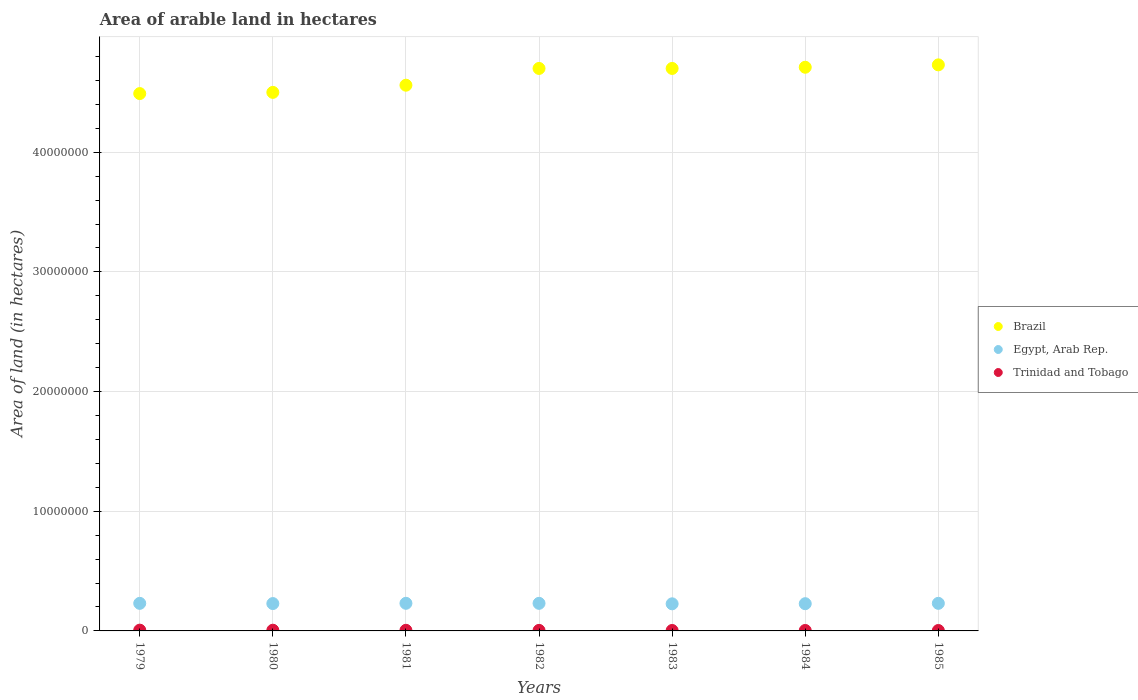What is the total arable land in Trinidad and Tobago in 1979?
Your response must be concise. 6.50e+04. Across all years, what is the maximum total arable land in Trinidad and Tobago?
Provide a short and direct response. 6.50e+04. Across all years, what is the minimum total arable land in Egypt, Arab Rep.?
Ensure brevity in your answer.  2.26e+06. In which year was the total arable land in Trinidad and Tobago maximum?
Provide a short and direct response. 1979. What is the total total arable land in Trinidad and Tobago in the graph?
Ensure brevity in your answer.  3.33e+05. What is the difference between the total arable land in Egypt, Arab Rep. in 1980 and that in 1982?
Your response must be concise. -1.90e+04. What is the difference between the total arable land in Trinidad and Tobago in 1985 and the total arable land in Egypt, Arab Rep. in 1981?
Ensure brevity in your answer.  -2.27e+06. What is the average total arable land in Egypt, Arab Rep. per year?
Ensure brevity in your answer.  2.29e+06. In the year 1985, what is the difference between the total arable land in Egypt, Arab Rep. and total arable land in Brazil?
Your answer should be compact. -4.50e+07. What is the ratio of the total arable land in Egypt, Arab Rep. in 1980 to that in 1982?
Your answer should be compact. 0.99. Is the total arable land in Trinidad and Tobago in 1979 less than that in 1983?
Give a very brief answer. No. What is the difference between the highest and the lowest total arable land in Egypt, Arab Rep.?
Offer a terse response. 4.23e+04. Is the sum of the total arable land in Brazil in 1981 and 1985 greater than the maximum total arable land in Trinidad and Tobago across all years?
Your answer should be compact. Yes. Is it the case that in every year, the sum of the total arable land in Brazil and total arable land in Trinidad and Tobago  is greater than the total arable land in Egypt, Arab Rep.?
Make the answer very short. Yes. How many dotlines are there?
Give a very brief answer. 3. Are the values on the major ticks of Y-axis written in scientific E-notation?
Keep it short and to the point. No. Where does the legend appear in the graph?
Offer a very short reply. Center right. What is the title of the graph?
Your answer should be very brief. Area of arable land in hectares. Does "Latin America(developing only)" appear as one of the legend labels in the graph?
Make the answer very short. No. What is the label or title of the Y-axis?
Provide a succinct answer. Area of land (in hectares). What is the Area of land (in hectares) of Brazil in 1979?
Offer a very short reply. 4.49e+07. What is the Area of land (in hectares) of Egypt, Arab Rep. in 1979?
Offer a very short reply. 2.30e+06. What is the Area of land (in hectares) in Trinidad and Tobago in 1979?
Make the answer very short. 6.50e+04. What is the Area of land (in hectares) of Brazil in 1980?
Your answer should be compact. 4.50e+07. What is the Area of land (in hectares) of Egypt, Arab Rep. in 1980?
Make the answer very short. 2.29e+06. What is the Area of land (in hectares) of Brazil in 1981?
Your answer should be compact. 4.56e+07. What is the Area of land (in hectares) of Egypt, Arab Rep. in 1981?
Provide a short and direct response. 2.31e+06. What is the Area of land (in hectares) in Trinidad and Tobago in 1981?
Your answer should be very brief. 5.20e+04. What is the Area of land (in hectares) in Brazil in 1982?
Keep it short and to the point. 4.70e+07. What is the Area of land (in hectares) of Egypt, Arab Rep. in 1982?
Provide a succinct answer. 2.30e+06. What is the Area of land (in hectares) in Trinidad and Tobago in 1982?
Provide a succinct answer. 4.50e+04. What is the Area of land (in hectares) of Brazil in 1983?
Make the answer very short. 4.70e+07. What is the Area of land (in hectares) of Egypt, Arab Rep. in 1983?
Provide a succinct answer. 2.26e+06. What is the Area of land (in hectares) in Trinidad and Tobago in 1983?
Offer a very short reply. 3.80e+04. What is the Area of land (in hectares) of Brazil in 1984?
Your answer should be very brief. 4.71e+07. What is the Area of land (in hectares) of Egypt, Arab Rep. in 1984?
Ensure brevity in your answer.  2.28e+06. What is the Area of land (in hectares) in Trinidad and Tobago in 1984?
Offer a very short reply. 3.80e+04. What is the Area of land (in hectares) of Brazil in 1985?
Make the answer very short. 4.73e+07. What is the Area of land (in hectares) of Egypt, Arab Rep. in 1985?
Offer a very short reply. 2.30e+06. What is the Area of land (in hectares) of Trinidad and Tobago in 1985?
Your answer should be compact. 3.50e+04. Across all years, what is the maximum Area of land (in hectares) in Brazil?
Give a very brief answer. 4.73e+07. Across all years, what is the maximum Area of land (in hectares) of Egypt, Arab Rep.?
Offer a terse response. 2.31e+06. Across all years, what is the maximum Area of land (in hectares) in Trinidad and Tobago?
Make the answer very short. 6.50e+04. Across all years, what is the minimum Area of land (in hectares) of Brazil?
Your answer should be compact. 4.49e+07. Across all years, what is the minimum Area of land (in hectares) in Egypt, Arab Rep.?
Make the answer very short. 2.26e+06. Across all years, what is the minimum Area of land (in hectares) of Trinidad and Tobago?
Keep it short and to the point. 3.50e+04. What is the total Area of land (in hectares) of Brazil in the graph?
Your answer should be very brief. 3.24e+08. What is the total Area of land (in hectares) of Egypt, Arab Rep. in the graph?
Keep it short and to the point. 1.60e+07. What is the total Area of land (in hectares) of Trinidad and Tobago in the graph?
Your response must be concise. 3.33e+05. What is the difference between the Area of land (in hectares) of Brazil in 1979 and that in 1980?
Your answer should be very brief. -1.00e+05. What is the difference between the Area of land (in hectares) of Egypt, Arab Rep. in 1979 and that in 1980?
Offer a very short reply. 1.80e+04. What is the difference between the Area of land (in hectares) in Brazil in 1979 and that in 1981?
Give a very brief answer. -7.00e+05. What is the difference between the Area of land (in hectares) of Egypt, Arab Rep. in 1979 and that in 1981?
Your answer should be compact. -3000. What is the difference between the Area of land (in hectares) in Trinidad and Tobago in 1979 and that in 1981?
Offer a very short reply. 1.30e+04. What is the difference between the Area of land (in hectares) in Brazil in 1979 and that in 1982?
Ensure brevity in your answer.  -2.10e+06. What is the difference between the Area of land (in hectares) in Egypt, Arab Rep. in 1979 and that in 1982?
Provide a succinct answer. -1000. What is the difference between the Area of land (in hectares) of Trinidad and Tobago in 1979 and that in 1982?
Offer a terse response. 2.00e+04. What is the difference between the Area of land (in hectares) of Brazil in 1979 and that in 1983?
Your answer should be very brief. -2.10e+06. What is the difference between the Area of land (in hectares) in Egypt, Arab Rep. in 1979 and that in 1983?
Your answer should be compact. 3.93e+04. What is the difference between the Area of land (in hectares) in Trinidad and Tobago in 1979 and that in 1983?
Make the answer very short. 2.70e+04. What is the difference between the Area of land (in hectares) of Brazil in 1979 and that in 1984?
Give a very brief answer. -2.20e+06. What is the difference between the Area of land (in hectares) in Egypt, Arab Rep. in 1979 and that in 1984?
Offer a very short reply. 2.87e+04. What is the difference between the Area of land (in hectares) of Trinidad and Tobago in 1979 and that in 1984?
Your answer should be very brief. 2.70e+04. What is the difference between the Area of land (in hectares) of Brazil in 1979 and that in 1985?
Your answer should be very brief. -2.40e+06. What is the difference between the Area of land (in hectares) in Egypt, Arab Rep. in 1979 and that in 1985?
Your answer should be very brief. -1000. What is the difference between the Area of land (in hectares) of Brazil in 1980 and that in 1981?
Give a very brief answer. -6.00e+05. What is the difference between the Area of land (in hectares) in Egypt, Arab Rep. in 1980 and that in 1981?
Ensure brevity in your answer.  -2.10e+04. What is the difference between the Area of land (in hectares) in Trinidad and Tobago in 1980 and that in 1981?
Make the answer very short. 8000. What is the difference between the Area of land (in hectares) in Brazil in 1980 and that in 1982?
Your response must be concise. -2.00e+06. What is the difference between the Area of land (in hectares) of Egypt, Arab Rep. in 1980 and that in 1982?
Your answer should be very brief. -1.90e+04. What is the difference between the Area of land (in hectares) of Trinidad and Tobago in 1980 and that in 1982?
Your answer should be compact. 1.50e+04. What is the difference between the Area of land (in hectares) in Egypt, Arab Rep. in 1980 and that in 1983?
Keep it short and to the point. 2.13e+04. What is the difference between the Area of land (in hectares) of Trinidad and Tobago in 1980 and that in 1983?
Give a very brief answer. 2.20e+04. What is the difference between the Area of land (in hectares) in Brazil in 1980 and that in 1984?
Make the answer very short. -2.10e+06. What is the difference between the Area of land (in hectares) in Egypt, Arab Rep. in 1980 and that in 1984?
Provide a short and direct response. 1.07e+04. What is the difference between the Area of land (in hectares) of Trinidad and Tobago in 1980 and that in 1984?
Offer a terse response. 2.20e+04. What is the difference between the Area of land (in hectares) in Brazil in 1980 and that in 1985?
Offer a terse response. -2.30e+06. What is the difference between the Area of land (in hectares) of Egypt, Arab Rep. in 1980 and that in 1985?
Provide a short and direct response. -1.90e+04. What is the difference between the Area of land (in hectares) in Trinidad and Tobago in 1980 and that in 1985?
Offer a terse response. 2.50e+04. What is the difference between the Area of land (in hectares) in Brazil in 1981 and that in 1982?
Keep it short and to the point. -1.40e+06. What is the difference between the Area of land (in hectares) in Trinidad and Tobago in 1981 and that in 1982?
Keep it short and to the point. 7000. What is the difference between the Area of land (in hectares) of Brazil in 1981 and that in 1983?
Give a very brief answer. -1.40e+06. What is the difference between the Area of land (in hectares) in Egypt, Arab Rep. in 1981 and that in 1983?
Your response must be concise. 4.23e+04. What is the difference between the Area of land (in hectares) of Trinidad and Tobago in 1981 and that in 1983?
Provide a succinct answer. 1.40e+04. What is the difference between the Area of land (in hectares) of Brazil in 1981 and that in 1984?
Offer a very short reply. -1.50e+06. What is the difference between the Area of land (in hectares) of Egypt, Arab Rep. in 1981 and that in 1984?
Ensure brevity in your answer.  3.17e+04. What is the difference between the Area of land (in hectares) in Trinidad and Tobago in 1981 and that in 1984?
Provide a succinct answer. 1.40e+04. What is the difference between the Area of land (in hectares) in Brazil in 1981 and that in 1985?
Offer a terse response. -1.70e+06. What is the difference between the Area of land (in hectares) of Egypt, Arab Rep. in 1981 and that in 1985?
Make the answer very short. 2000. What is the difference between the Area of land (in hectares) of Trinidad and Tobago in 1981 and that in 1985?
Make the answer very short. 1.70e+04. What is the difference between the Area of land (in hectares) in Brazil in 1982 and that in 1983?
Give a very brief answer. 0. What is the difference between the Area of land (in hectares) in Egypt, Arab Rep. in 1982 and that in 1983?
Your response must be concise. 4.03e+04. What is the difference between the Area of land (in hectares) in Trinidad and Tobago in 1982 and that in 1983?
Offer a terse response. 7000. What is the difference between the Area of land (in hectares) in Brazil in 1982 and that in 1984?
Provide a short and direct response. -1.00e+05. What is the difference between the Area of land (in hectares) in Egypt, Arab Rep. in 1982 and that in 1984?
Make the answer very short. 2.97e+04. What is the difference between the Area of land (in hectares) of Trinidad and Tobago in 1982 and that in 1984?
Provide a succinct answer. 7000. What is the difference between the Area of land (in hectares) in Egypt, Arab Rep. in 1983 and that in 1984?
Ensure brevity in your answer.  -1.05e+04. What is the difference between the Area of land (in hectares) of Trinidad and Tobago in 1983 and that in 1984?
Provide a short and direct response. 0. What is the difference between the Area of land (in hectares) of Egypt, Arab Rep. in 1983 and that in 1985?
Keep it short and to the point. -4.03e+04. What is the difference between the Area of land (in hectares) in Trinidad and Tobago in 1983 and that in 1985?
Your answer should be compact. 3000. What is the difference between the Area of land (in hectares) in Egypt, Arab Rep. in 1984 and that in 1985?
Make the answer very short. -2.97e+04. What is the difference between the Area of land (in hectares) in Trinidad and Tobago in 1984 and that in 1985?
Keep it short and to the point. 3000. What is the difference between the Area of land (in hectares) in Brazil in 1979 and the Area of land (in hectares) in Egypt, Arab Rep. in 1980?
Ensure brevity in your answer.  4.26e+07. What is the difference between the Area of land (in hectares) in Brazil in 1979 and the Area of land (in hectares) in Trinidad and Tobago in 1980?
Offer a terse response. 4.48e+07. What is the difference between the Area of land (in hectares) in Egypt, Arab Rep. in 1979 and the Area of land (in hectares) in Trinidad and Tobago in 1980?
Keep it short and to the point. 2.24e+06. What is the difference between the Area of land (in hectares) of Brazil in 1979 and the Area of land (in hectares) of Egypt, Arab Rep. in 1981?
Give a very brief answer. 4.26e+07. What is the difference between the Area of land (in hectares) of Brazil in 1979 and the Area of land (in hectares) of Trinidad and Tobago in 1981?
Provide a succinct answer. 4.48e+07. What is the difference between the Area of land (in hectares) in Egypt, Arab Rep. in 1979 and the Area of land (in hectares) in Trinidad and Tobago in 1981?
Make the answer very short. 2.25e+06. What is the difference between the Area of land (in hectares) of Brazil in 1979 and the Area of land (in hectares) of Egypt, Arab Rep. in 1982?
Provide a short and direct response. 4.26e+07. What is the difference between the Area of land (in hectares) of Brazil in 1979 and the Area of land (in hectares) of Trinidad and Tobago in 1982?
Give a very brief answer. 4.49e+07. What is the difference between the Area of land (in hectares) of Egypt, Arab Rep. in 1979 and the Area of land (in hectares) of Trinidad and Tobago in 1982?
Ensure brevity in your answer.  2.26e+06. What is the difference between the Area of land (in hectares) in Brazil in 1979 and the Area of land (in hectares) in Egypt, Arab Rep. in 1983?
Your answer should be compact. 4.26e+07. What is the difference between the Area of land (in hectares) in Brazil in 1979 and the Area of land (in hectares) in Trinidad and Tobago in 1983?
Ensure brevity in your answer.  4.49e+07. What is the difference between the Area of land (in hectares) in Egypt, Arab Rep. in 1979 and the Area of land (in hectares) in Trinidad and Tobago in 1983?
Offer a terse response. 2.27e+06. What is the difference between the Area of land (in hectares) of Brazil in 1979 and the Area of land (in hectares) of Egypt, Arab Rep. in 1984?
Ensure brevity in your answer.  4.26e+07. What is the difference between the Area of land (in hectares) in Brazil in 1979 and the Area of land (in hectares) in Trinidad and Tobago in 1984?
Provide a short and direct response. 4.49e+07. What is the difference between the Area of land (in hectares) of Egypt, Arab Rep. in 1979 and the Area of land (in hectares) of Trinidad and Tobago in 1984?
Your response must be concise. 2.27e+06. What is the difference between the Area of land (in hectares) in Brazil in 1979 and the Area of land (in hectares) in Egypt, Arab Rep. in 1985?
Provide a succinct answer. 4.26e+07. What is the difference between the Area of land (in hectares) in Brazil in 1979 and the Area of land (in hectares) in Trinidad and Tobago in 1985?
Provide a succinct answer. 4.49e+07. What is the difference between the Area of land (in hectares) of Egypt, Arab Rep. in 1979 and the Area of land (in hectares) of Trinidad and Tobago in 1985?
Provide a short and direct response. 2.27e+06. What is the difference between the Area of land (in hectares) of Brazil in 1980 and the Area of land (in hectares) of Egypt, Arab Rep. in 1981?
Your answer should be compact. 4.27e+07. What is the difference between the Area of land (in hectares) in Brazil in 1980 and the Area of land (in hectares) in Trinidad and Tobago in 1981?
Offer a very short reply. 4.49e+07. What is the difference between the Area of land (in hectares) of Egypt, Arab Rep. in 1980 and the Area of land (in hectares) of Trinidad and Tobago in 1981?
Ensure brevity in your answer.  2.23e+06. What is the difference between the Area of land (in hectares) of Brazil in 1980 and the Area of land (in hectares) of Egypt, Arab Rep. in 1982?
Keep it short and to the point. 4.27e+07. What is the difference between the Area of land (in hectares) of Brazil in 1980 and the Area of land (in hectares) of Trinidad and Tobago in 1982?
Your answer should be very brief. 4.50e+07. What is the difference between the Area of land (in hectares) in Egypt, Arab Rep. in 1980 and the Area of land (in hectares) in Trinidad and Tobago in 1982?
Offer a very short reply. 2.24e+06. What is the difference between the Area of land (in hectares) in Brazil in 1980 and the Area of land (in hectares) in Egypt, Arab Rep. in 1983?
Your response must be concise. 4.27e+07. What is the difference between the Area of land (in hectares) in Brazil in 1980 and the Area of land (in hectares) in Trinidad and Tobago in 1983?
Your response must be concise. 4.50e+07. What is the difference between the Area of land (in hectares) in Egypt, Arab Rep. in 1980 and the Area of land (in hectares) in Trinidad and Tobago in 1983?
Ensure brevity in your answer.  2.25e+06. What is the difference between the Area of land (in hectares) of Brazil in 1980 and the Area of land (in hectares) of Egypt, Arab Rep. in 1984?
Keep it short and to the point. 4.27e+07. What is the difference between the Area of land (in hectares) of Brazil in 1980 and the Area of land (in hectares) of Trinidad and Tobago in 1984?
Provide a short and direct response. 4.50e+07. What is the difference between the Area of land (in hectares) in Egypt, Arab Rep. in 1980 and the Area of land (in hectares) in Trinidad and Tobago in 1984?
Ensure brevity in your answer.  2.25e+06. What is the difference between the Area of land (in hectares) in Brazil in 1980 and the Area of land (in hectares) in Egypt, Arab Rep. in 1985?
Your answer should be very brief. 4.27e+07. What is the difference between the Area of land (in hectares) in Brazil in 1980 and the Area of land (in hectares) in Trinidad and Tobago in 1985?
Your answer should be compact. 4.50e+07. What is the difference between the Area of land (in hectares) in Egypt, Arab Rep. in 1980 and the Area of land (in hectares) in Trinidad and Tobago in 1985?
Make the answer very short. 2.25e+06. What is the difference between the Area of land (in hectares) of Brazil in 1981 and the Area of land (in hectares) of Egypt, Arab Rep. in 1982?
Ensure brevity in your answer.  4.33e+07. What is the difference between the Area of land (in hectares) of Brazil in 1981 and the Area of land (in hectares) of Trinidad and Tobago in 1982?
Ensure brevity in your answer.  4.56e+07. What is the difference between the Area of land (in hectares) of Egypt, Arab Rep. in 1981 and the Area of land (in hectares) of Trinidad and Tobago in 1982?
Provide a succinct answer. 2.26e+06. What is the difference between the Area of land (in hectares) of Brazil in 1981 and the Area of land (in hectares) of Egypt, Arab Rep. in 1983?
Provide a succinct answer. 4.33e+07. What is the difference between the Area of land (in hectares) of Brazil in 1981 and the Area of land (in hectares) of Trinidad and Tobago in 1983?
Ensure brevity in your answer.  4.56e+07. What is the difference between the Area of land (in hectares) of Egypt, Arab Rep. in 1981 and the Area of land (in hectares) of Trinidad and Tobago in 1983?
Provide a short and direct response. 2.27e+06. What is the difference between the Area of land (in hectares) of Brazil in 1981 and the Area of land (in hectares) of Egypt, Arab Rep. in 1984?
Your answer should be compact. 4.33e+07. What is the difference between the Area of land (in hectares) of Brazil in 1981 and the Area of land (in hectares) of Trinidad and Tobago in 1984?
Provide a succinct answer. 4.56e+07. What is the difference between the Area of land (in hectares) in Egypt, Arab Rep. in 1981 and the Area of land (in hectares) in Trinidad and Tobago in 1984?
Keep it short and to the point. 2.27e+06. What is the difference between the Area of land (in hectares) in Brazil in 1981 and the Area of land (in hectares) in Egypt, Arab Rep. in 1985?
Offer a terse response. 4.33e+07. What is the difference between the Area of land (in hectares) in Brazil in 1981 and the Area of land (in hectares) in Trinidad and Tobago in 1985?
Your answer should be compact. 4.56e+07. What is the difference between the Area of land (in hectares) of Egypt, Arab Rep. in 1981 and the Area of land (in hectares) of Trinidad and Tobago in 1985?
Your response must be concise. 2.27e+06. What is the difference between the Area of land (in hectares) of Brazil in 1982 and the Area of land (in hectares) of Egypt, Arab Rep. in 1983?
Keep it short and to the point. 4.47e+07. What is the difference between the Area of land (in hectares) in Brazil in 1982 and the Area of land (in hectares) in Trinidad and Tobago in 1983?
Your answer should be very brief. 4.70e+07. What is the difference between the Area of land (in hectares) in Egypt, Arab Rep. in 1982 and the Area of land (in hectares) in Trinidad and Tobago in 1983?
Your answer should be very brief. 2.27e+06. What is the difference between the Area of land (in hectares) in Brazil in 1982 and the Area of land (in hectares) in Egypt, Arab Rep. in 1984?
Your answer should be very brief. 4.47e+07. What is the difference between the Area of land (in hectares) of Brazil in 1982 and the Area of land (in hectares) of Trinidad and Tobago in 1984?
Make the answer very short. 4.70e+07. What is the difference between the Area of land (in hectares) of Egypt, Arab Rep. in 1982 and the Area of land (in hectares) of Trinidad and Tobago in 1984?
Your response must be concise. 2.27e+06. What is the difference between the Area of land (in hectares) of Brazil in 1982 and the Area of land (in hectares) of Egypt, Arab Rep. in 1985?
Make the answer very short. 4.47e+07. What is the difference between the Area of land (in hectares) in Brazil in 1982 and the Area of land (in hectares) in Trinidad and Tobago in 1985?
Make the answer very short. 4.70e+07. What is the difference between the Area of land (in hectares) in Egypt, Arab Rep. in 1982 and the Area of land (in hectares) in Trinidad and Tobago in 1985?
Keep it short and to the point. 2.27e+06. What is the difference between the Area of land (in hectares) in Brazil in 1983 and the Area of land (in hectares) in Egypt, Arab Rep. in 1984?
Your response must be concise. 4.47e+07. What is the difference between the Area of land (in hectares) in Brazil in 1983 and the Area of land (in hectares) in Trinidad and Tobago in 1984?
Give a very brief answer. 4.70e+07. What is the difference between the Area of land (in hectares) in Egypt, Arab Rep. in 1983 and the Area of land (in hectares) in Trinidad and Tobago in 1984?
Make the answer very short. 2.23e+06. What is the difference between the Area of land (in hectares) of Brazil in 1983 and the Area of land (in hectares) of Egypt, Arab Rep. in 1985?
Ensure brevity in your answer.  4.47e+07. What is the difference between the Area of land (in hectares) in Brazil in 1983 and the Area of land (in hectares) in Trinidad and Tobago in 1985?
Make the answer very short. 4.70e+07. What is the difference between the Area of land (in hectares) of Egypt, Arab Rep. in 1983 and the Area of land (in hectares) of Trinidad and Tobago in 1985?
Offer a terse response. 2.23e+06. What is the difference between the Area of land (in hectares) in Brazil in 1984 and the Area of land (in hectares) in Egypt, Arab Rep. in 1985?
Offer a very short reply. 4.48e+07. What is the difference between the Area of land (in hectares) of Brazil in 1984 and the Area of land (in hectares) of Trinidad and Tobago in 1985?
Give a very brief answer. 4.71e+07. What is the difference between the Area of land (in hectares) of Egypt, Arab Rep. in 1984 and the Area of land (in hectares) of Trinidad and Tobago in 1985?
Provide a short and direct response. 2.24e+06. What is the average Area of land (in hectares) in Brazil per year?
Your answer should be very brief. 4.63e+07. What is the average Area of land (in hectares) in Egypt, Arab Rep. per year?
Your answer should be compact. 2.29e+06. What is the average Area of land (in hectares) in Trinidad and Tobago per year?
Your response must be concise. 4.76e+04. In the year 1979, what is the difference between the Area of land (in hectares) in Brazil and Area of land (in hectares) in Egypt, Arab Rep.?
Make the answer very short. 4.26e+07. In the year 1979, what is the difference between the Area of land (in hectares) of Brazil and Area of land (in hectares) of Trinidad and Tobago?
Offer a very short reply. 4.48e+07. In the year 1979, what is the difference between the Area of land (in hectares) in Egypt, Arab Rep. and Area of land (in hectares) in Trinidad and Tobago?
Offer a very short reply. 2.24e+06. In the year 1980, what is the difference between the Area of land (in hectares) of Brazil and Area of land (in hectares) of Egypt, Arab Rep.?
Provide a succinct answer. 4.27e+07. In the year 1980, what is the difference between the Area of land (in hectares) in Brazil and Area of land (in hectares) in Trinidad and Tobago?
Give a very brief answer. 4.49e+07. In the year 1980, what is the difference between the Area of land (in hectares) in Egypt, Arab Rep. and Area of land (in hectares) in Trinidad and Tobago?
Give a very brief answer. 2.23e+06. In the year 1981, what is the difference between the Area of land (in hectares) in Brazil and Area of land (in hectares) in Egypt, Arab Rep.?
Offer a very short reply. 4.33e+07. In the year 1981, what is the difference between the Area of land (in hectares) in Brazil and Area of land (in hectares) in Trinidad and Tobago?
Offer a terse response. 4.55e+07. In the year 1981, what is the difference between the Area of land (in hectares) in Egypt, Arab Rep. and Area of land (in hectares) in Trinidad and Tobago?
Your answer should be compact. 2.26e+06. In the year 1982, what is the difference between the Area of land (in hectares) in Brazil and Area of land (in hectares) in Egypt, Arab Rep.?
Make the answer very short. 4.47e+07. In the year 1982, what is the difference between the Area of land (in hectares) in Brazil and Area of land (in hectares) in Trinidad and Tobago?
Your answer should be compact. 4.70e+07. In the year 1982, what is the difference between the Area of land (in hectares) in Egypt, Arab Rep. and Area of land (in hectares) in Trinidad and Tobago?
Your response must be concise. 2.26e+06. In the year 1983, what is the difference between the Area of land (in hectares) of Brazil and Area of land (in hectares) of Egypt, Arab Rep.?
Offer a very short reply. 4.47e+07. In the year 1983, what is the difference between the Area of land (in hectares) of Brazil and Area of land (in hectares) of Trinidad and Tobago?
Your answer should be very brief. 4.70e+07. In the year 1983, what is the difference between the Area of land (in hectares) of Egypt, Arab Rep. and Area of land (in hectares) of Trinidad and Tobago?
Your answer should be very brief. 2.23e+06. In the year 1984, what is the difference between the Area of land (in hectares) in Brazil and Area of land (in hectares) in Egypt, Arab Rep.?
Provide a short and direct response. 4.48e+07. In the year 1984, what is the difference between the Area of land (in hectares) in Brazil and Area of land (in hectares) in Trinidad and Tobago?
Offer a terse response. 4.71e+07. In the year 1984, what is the difference between the Area of land (in hectares) in Egypt, Arab Rep. and Area of land (in hectares) in Trinidad and Tobago?
Provide a short and direct response. 2.24e+06. In the year 1985, what is the difference between the Area of land (in hectares) of Brazil and Area of land (in hectares) of Egypt, Arab Rep.?
Offer a very short reply. 4.50e+07. In the year 1985, what is the difference between the Area of land (in hectares) in Brazil and Area of land (in hectares) in Trinidad and Tobago?
Ensure brevity in your answer.  4.73e+07. In the year 1985, what is the difference between the Area of land (in hectares) in Egypt, Arab Rep. and Area of land (in hectares) in Trinidad and Tobago?
Provide a short and direct response. 2.27e+06. What is the ratio of the Area of land (in hectares) in Brazil in 1979 to that in 1980?
Your answer should be compact. 1. What is the ratio of the Area of land (in hectares) in Egypt, Arab Rep. in 1979 to that in 1980?
Ensure brevity in your answer.  1.01. What is the ratio of the Area of land (in hectares) in Trinidad and Tobago in 1979 to that in 1980?
Provide a short and direct response. 1.08. What is the ratio of the Area of land (in hectares) of Brazil in 1979 to that in 1981?
Your answer should be very brief. 0.98. What is the ratio of the Area of land (in hectares) of Egypt, Arab Rep. in 1979 to that in 1981?
Your answer should be compact. 1. What is the ratio of the Area of land (in hectares) in Brazil in 1979 to that in 1982?
Offer a terse response. 0.96. What is the ratio of the Area of land (in hectares) in Egypt, Arab Rep. in 1979 to that in 1982?
Offer a terse response. 1. What is the ratio of the Area of land (in hectares) in Trinidad and Tobago in 1979 to that in 1982?
Offer a terse response. 1.44. What is the ratio of the Area of land (in hectares) of Brazil in 1979 to that in 1983?
Offer a very short reply. 0.96. What is the ratio of the Area of land (in hectares) of Egypt, Arab Rep. in 1979 to that in 1983?
Your answer should be very brief. 1.02. What is the ratio of the Area of land (in hectares) of Trinidad and Tobago in 1979 to that in 1983?
Your answer should be compact. 1.71. What is the ratio of the Area of land (in hectares) in Brazil in 1979 to that in 1984?
Keep it short and to the point. 0.95. What is the ratio of the Area of land (in hectares) in Egypt, Arab Rep. in 1979 to that in 1984?
Your response must be concise. 1.01. What is the ratio of the Area of land (in hectares) in Trinidad and Tobago in 1979 to that in 1984?
Provide a succinct answer. 1.71. What is the ratio of the Area of land (in hectares) in Brazil in 1979 to that in 1985?
Give a very brief answer. 0.95. What is the ratio of the Area of land (in hectares) in Egypt, Arab Rep. in 1979 to that in 1985?
Provide a short and direct response. 1. What is the ratio of the Area of land (in hectares) of Trinidad and Tobago in 1979 to that in 1985?
Provide a short and direct response. 1.86. What is the ratio of the Area of land (in hectares) of Brazil in 1980 to that in 1981?
Your answer should be compact. 0.99. What is the ratio of the Area of land (in hectares) of Egypt, Arab Rep. in 1980 to that in 1981?
Your response must be concise. 0.99. What is the ratio of the Area of land (in hectares) of Trinidad and Tobago in 1980 to that in 1981?
Provide a short and direct response. 1.15. What is the ratio of the Area of land (in hectares) in Brazil in 1980 to that in 1982?
Provide a short and direct response. 0.96. What is the ratio of the Area of land (in hectares) of Egypt, Arab Rep. in 1980 to that in 1982?
Your response must be concise. 0.99. What is the ratio of the Area of land (in hectares) in Brazil in 1980 to that in 1983?
Offer a very short reply. 0.96. What is the ratio of the Area of land (in hectares) of Egypt, Arab Rep. in 1980 to that in 1983?
Provide a short and direct response. 1.01. What is the ratio of the Area of land (in hectares) of Trinidad and Tobago in 1980 to that in 1983?
Ensure brevity in your answer.  1.58. What is the ratio of the Area of land (in hectares) of Brazil in 1980 to that in 1984?
Offer a terse response. 0.96. What is the ratio of the Area of land (in hectares) in Trinidad and Tobago in 1980 to that in 1984?
Your response must be concise. 1.58. What is the ratio of the Area of land (in hectares) of Brazil in 1980 to that in 1985?
Make the answer very short. 0.95. What is the ratio of the Area of land (in hectares) of Egypt, Arab Rep. in 1980 to that in 1985?
Keep it short and to the point. 0.99. What is the ratio of the Area of land (in hectares) of Trinidad and Tobago in 1980 to that in 1985?
Provide a short and direct response. 1.71. What is the ratio of the Area of land (in hectares) in Brazil in 1981 to that in 1982?
Offer a terse response. 0.97. What is the ratio of the Area of land (in hectares) in Trinidad and Tobago in 1981 to that in 1982?
Keep it short and to the point. 1.16. What is the ratio of the Area of land (in hectares) in Brazil in 1981 to that in 1983?
Keep it short and to the point. 0.97. What is the ratio of the Area of land (in hectares) in Egypt, Arab Rep. in 1981 to that in 1983?
Provide a short and direct response. 1.02. What is the ratio of the Area of land (in hectares) of Trinidad and Tobago in 1981 to that in 1983?
Provide a short and direct response. 1.37. What is the ratio of the Area of land (in hectares) of Brazil in 1981 to that in 1984?
Provide a short and direct response. 0.97. What is the ratio of the Area of land (in hectares) in Egypt, Arab Rep. in 1981 to that in 1984?
Your answer should be very brief. 1.01. What is the ratio of the Area of land (in hectares) of Trinidad and Tobago in 1981 to that in 1984?
Give a very brief answer. 1.37. What is the ratio of the Area of land (in hectares) of Brazil in 1981 to that in 1985?
Keep it short and to the point. 0.96. What is the ratio of the Area of land (in hectares) in Egypt, Arab Rep. in 1981 to that in 1985?
Offer a very short reply. 1. What is the ratio of the Area of land (in hectares) in Trinidad and Tobago in 1981 to that in 1985?
Provide a short and direct response. 1.49. What is the ratio of the Area of land (in hectares) in Brazil in 1982 to that in 1983?
Provide a short and direct response. 1. What is the ratio of the Area of land (in hectares) of Egypt, Arab Rep. in 1982 to that in 1983?
Make the answer very short. 1.02. What is the ratio of the Area of land (in hectares) of Trinidad and Tobago in 1982 to that in 1983?
Provide a short and direct response. 1.18. What is the ratio of the Area of land (in hectares) of Brazil in 1982 to that in 1984?
Offer a very short reply. 1. What is the ratio of the Area of land (in hectares) of Egypt, Arab Rep. in 1982 to that in 1984?
Ensure brevity in your answer.  1.01. What is the ratio of the Area of land (in hectares) of Trinidad and Tobago in 1982 to that in 1984?
Ensure brevity in your answer.  1.18. What is the ratio of the Area of land (in hectares) of Trinidad and Tobago in 1982 to that in 1985?
Ensure brevity in your answer.  1.29. What is the ratio of the Area of land (in hectares) of Brazil in 1983 to that in 1984?
Keep it short and to the point. 1. What is the ratio of the Area of land (in hectares) of Egypt, Arab Rep. in 1983 to that in 1984?
Keep it short and to the point. 1. What is the ratio of the Area of land (in hectares) of Egypt, Arab Rep. in 1983 to that in 1985?
Your answer should be very brief. 0.98. What is the ratio of the Area of land (in hectares) of Trinidad and Tobago in 1983 to that in 1985?
Ensure brevity in your answer.  1.09. What is the ratio of the Area of land (in hectares) in Egypt, Arab Rep. in 1984 to that in 1985?
Give a very brief answer. 0.99. What is the ratio of the Area of land (in hectares) of Trinidad and Tobago in 1984 to that in 1985?
Keep it short and to the point. 1.09. What is the difference between the highest and the second highest Area of land (in hectares) of Brazil?
Ensure brevity in your answer.  2.00e+05. What is the difference between the highest and the second highest Area of land (in hectares) in Trinidad and Tobago?
Offer a very short reply. 5000. What is the difference between the highest and the lowest Area of land (in hectares) of Brazil?
Your answer should be very brief. 2.40e+06. What is the difference between the highest and the lowest Area of land (in hectares) of Egypt, Arab Rep.?
Provide a short and direct response. 4.23e+04. 